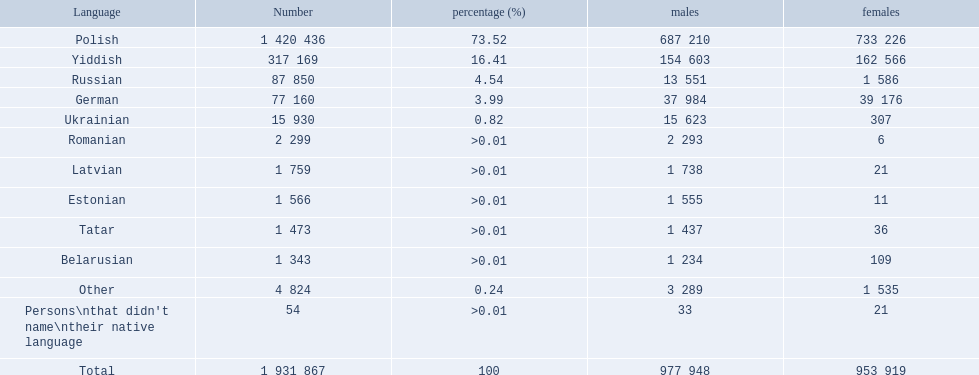What are the various languages spoken in the warsaw governorate? Polish, Yiddish, Russian, German, Ukrainian, Romanian, Latvian, Estonian, Tatar, Belarusian, Other, Persons\nthat didn't name\ntheir native language. Which language had the smallest number of female speakers? Romanian. What are all the spoken languages? Polish, Yiddish, Russian, German, Ukrainian, Romanian, Latvian, Estonian, Tatar, Belarusian. Which one of these is spoken by the most individuals? Polish. What designated indigenous languages spoken in the warsaw governorate have more men than women? Russian, Ukrainian, Romanian, Latvian, Estonian, Tatar, Belarusian. Which of those have fewer than 500 men listed? Romanian, Latvian, Estonian, Tatar, Belarusian. Of the remaining languages, which of them have fewer than 20 women? Romanian, Estonian. Which of these has the greatest total number listed? Romanian. What is the total number of languages presented? Polish, Yiddish, Russian, German, Ukrainian, Romanian, Latvian, Estonian, Tatar, Belarusian, Other. What is the third language in the list? Russian. After that language, which one has the most speakers? German. 